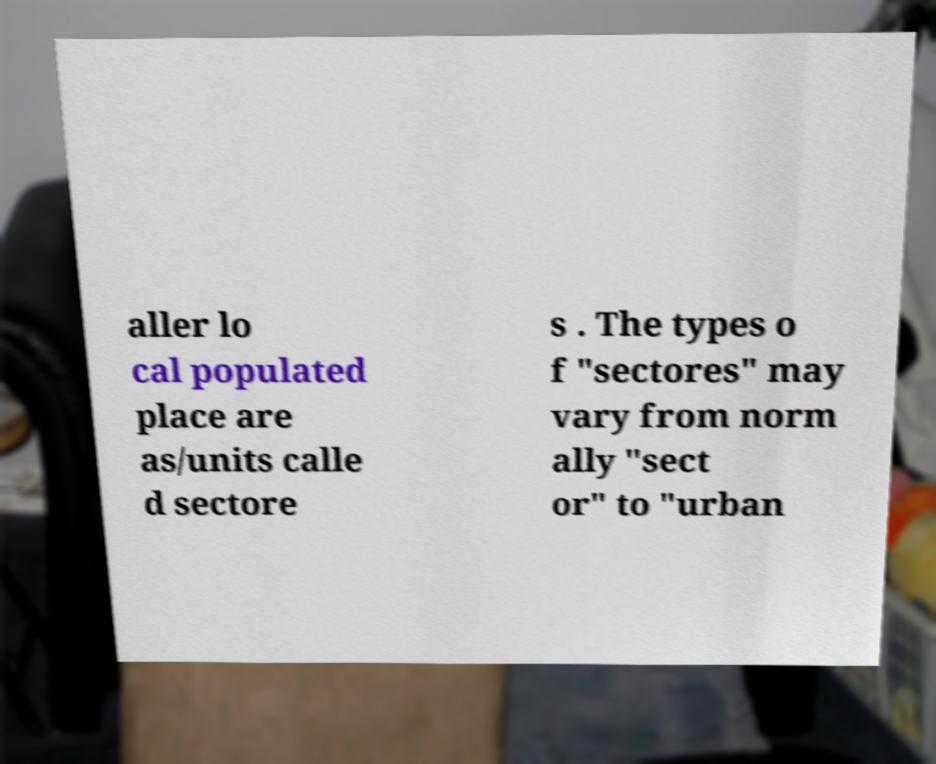Please identify and transcribe the text found in this image. aller lo cal populated place are as/units calle d sectore s . The types o f "sectores" may vary from norm ally "sect or" to "urban 